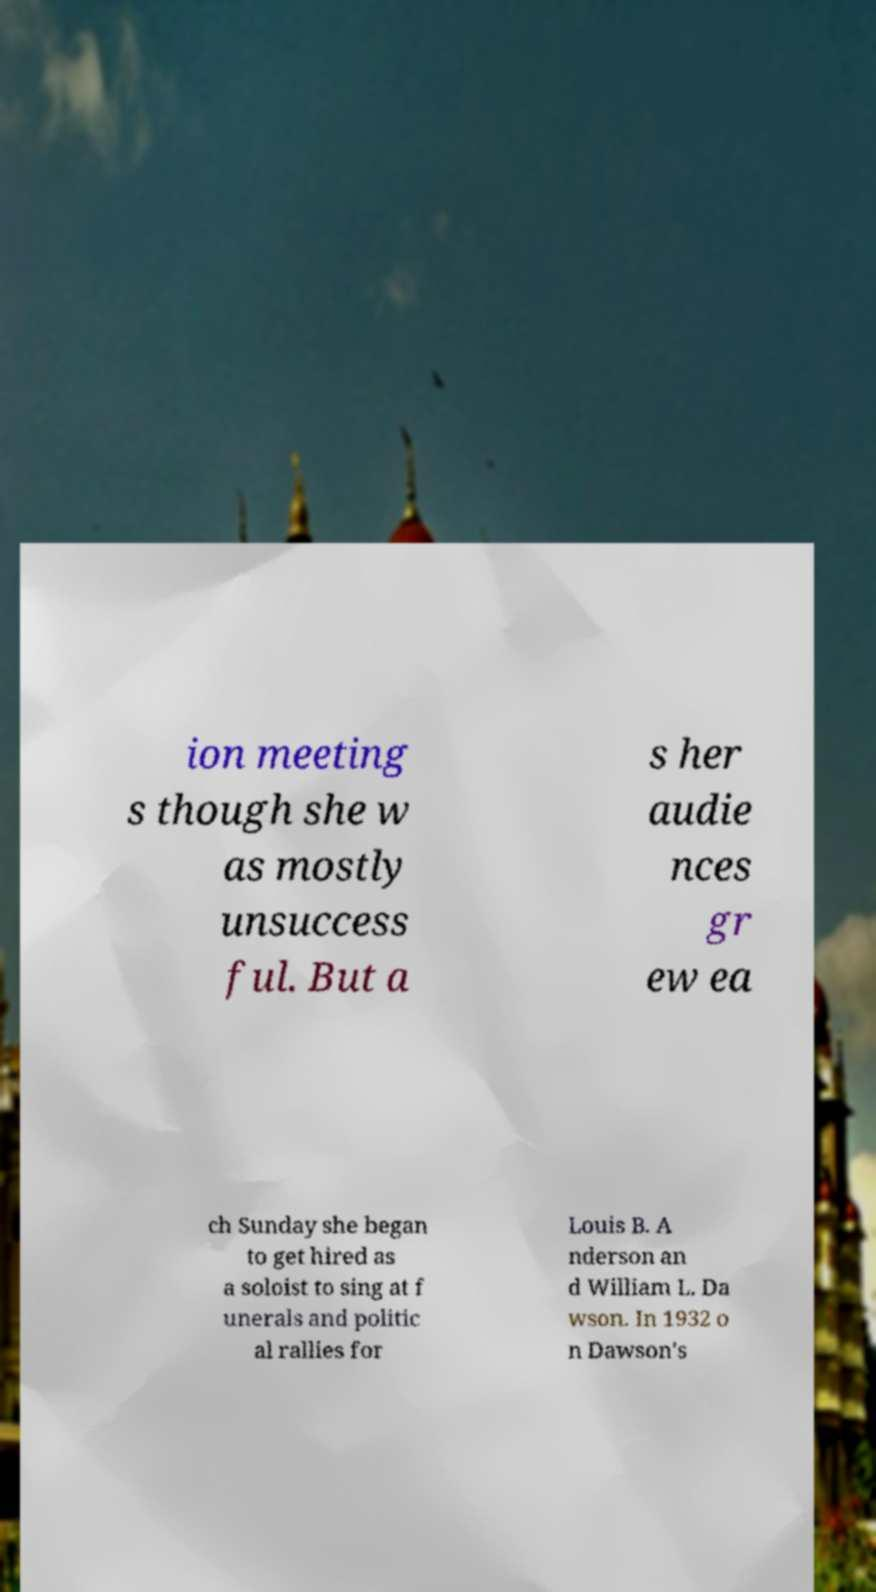Could you extract and type out the text from this image? ion meeting s though she w as mostly unsuccess ful. But a s her audie nces gr ew ea ch Sunday she began to get hired as a soloist to sing at f unerals and politic al rallies for Louis B. A nderson an d William L. Da wson. In 1932 o n Dawson's 